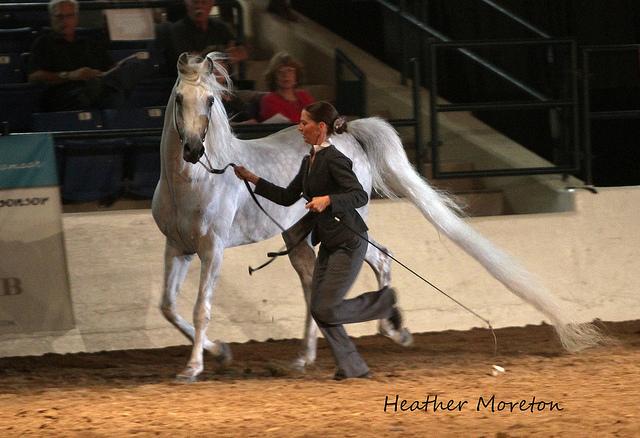Is the woman running?
Quick response, please. Yes. Is the horse racing?
Give a very brief answer. No. Where is the horse?
Quick response, please. Arena. 